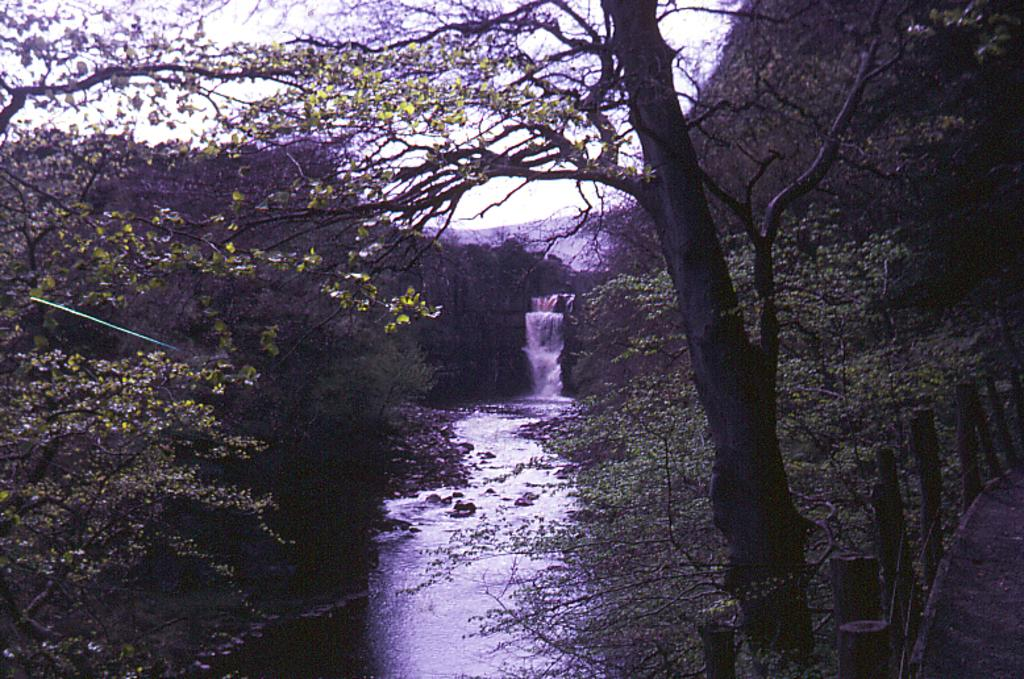What natural feature is the main subject of the image? There is a waterfall in the image. What type of vegetation is present on the right side of the image? There are many trees on the right side of the image. What can be seen in the background of the image? There is a mountain visible in the background of the image. What is visible in the sky in the image? The sky is visible in the image. What is present at the bottom of the image? There is water at the bottom of the image. What type of beef is being grilled on the top of the waterfall in the image? There is no beef or grilling activity present in the image; it features a waterfall and its surrounding environment. 